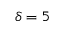Convert formula to latex. <formula><loc_0><loc_0><loc_500><loc_500>\delta = 5</formula> 